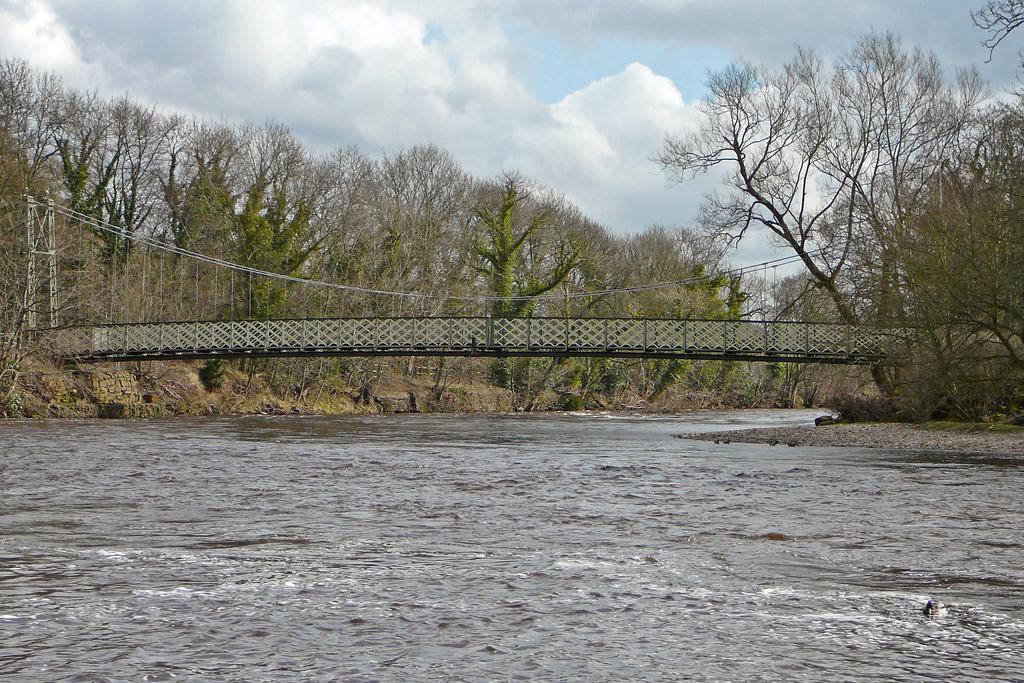Can you describe this image briefly? This image is taken outdoors. At the top of the image there is a sky with clouds. At the bottom of the image there is a lake with water. In the middle of the image there is a bridge. In the background there are many trees and plants on the ground. 